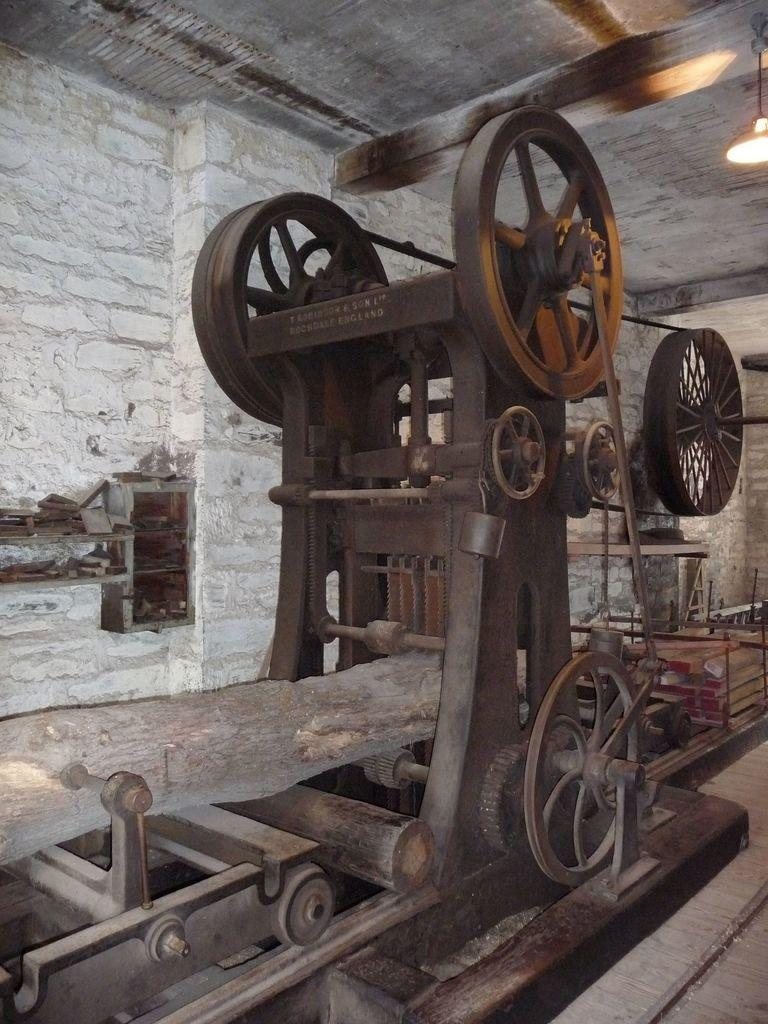What is the main subject in the picture? There is a machine in the picture. What can be seen in the background of the picture? There is a wall in the background of the picture, and there are lights on the ceiling. Are there any other objects visible in the background? Yes, there are other objects visible in the background. What type of vacation did the person's aunt take last year? There is no information about a person, their aunt, or a vacation in the image, so it cannot be determined from the picture. 